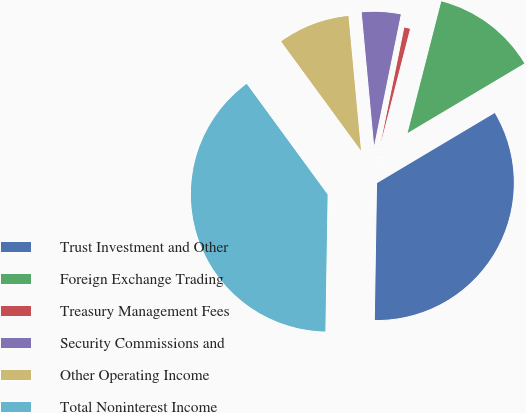Convert chart to OTSL. <chart><loc_0><loc_0><loc_500><loc_500><pie_chart><fcel>Trust Investment and Other<fcel>Foreign Exchange Trading<fcel>Treasury Management Fees<fcel>Security Commissions and<fcel>Other Operating Income<fcel>Total Noninterest Income<nl><fcel>33.81%<fcel>12.46%<fcel>0.79%<fcel>4.68%<fcel>8.57%<fcel>39.69%<nl></chart> 